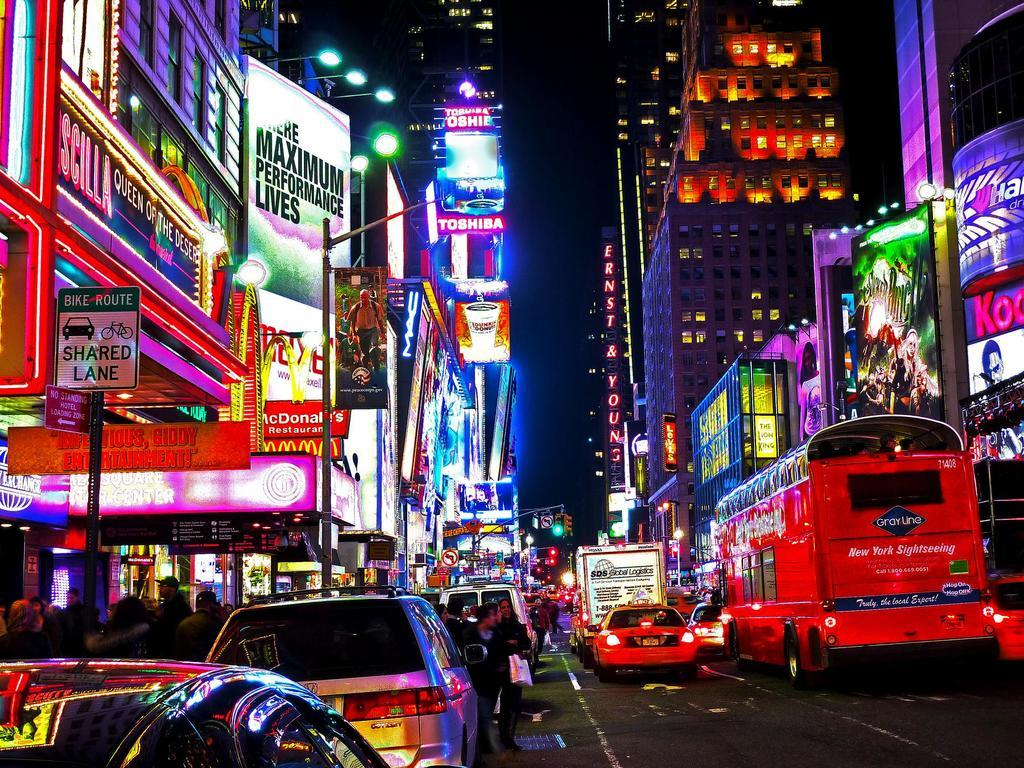<image>
Summarize the visual content of the image. Night streetview with a McDonalds on the side. 